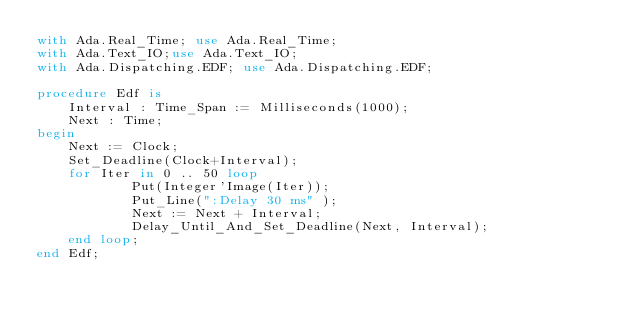Convert code to text. <code><loc_0><loc_0><loc_500><loc_500><_Ada_>with Ada.Real_Time; use Ada.Real_Time;
with Ada.Text_IO;use Ada.Text_IO;
with Ada.Dispatching.EDF; use Ada.Dispatching.EDF;

procedure Edf is
	Interval : Time_Span := Milliseconds(1000);
	Next : Time;
begin
	Next := Clock;
	Set_Deadline(Clock+Interval);
	for Iter in 0 .. 50 loop
			Put(Integer'Image(Iter));	
			Put_Line(":Delay 30 ms" );
			Next := Next + Interval;
			Delay_Until_And_Set_Deadline(Next, Interval);
	end loop;
end Edf;

</code> 